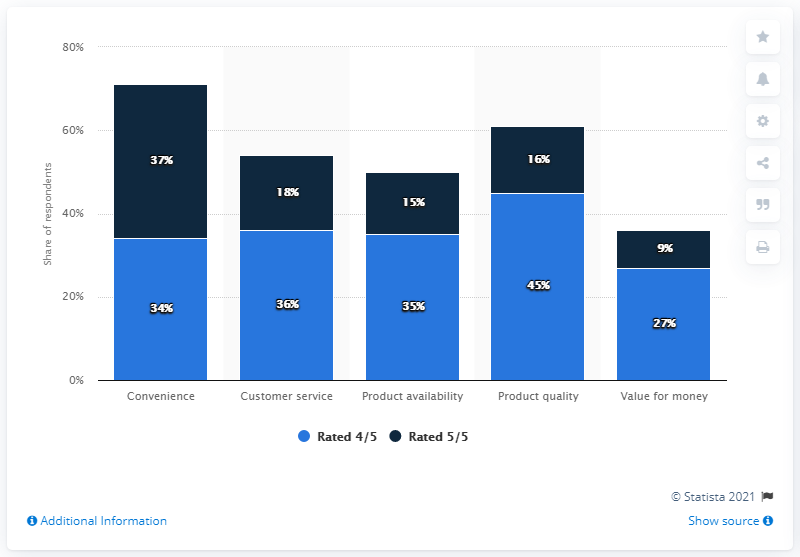Identify some key points in this picture. The recorded sales of 35% and 15% indicate that product availability is a critical factor in the category. The average of all the blue bars is approximately 35.4. 